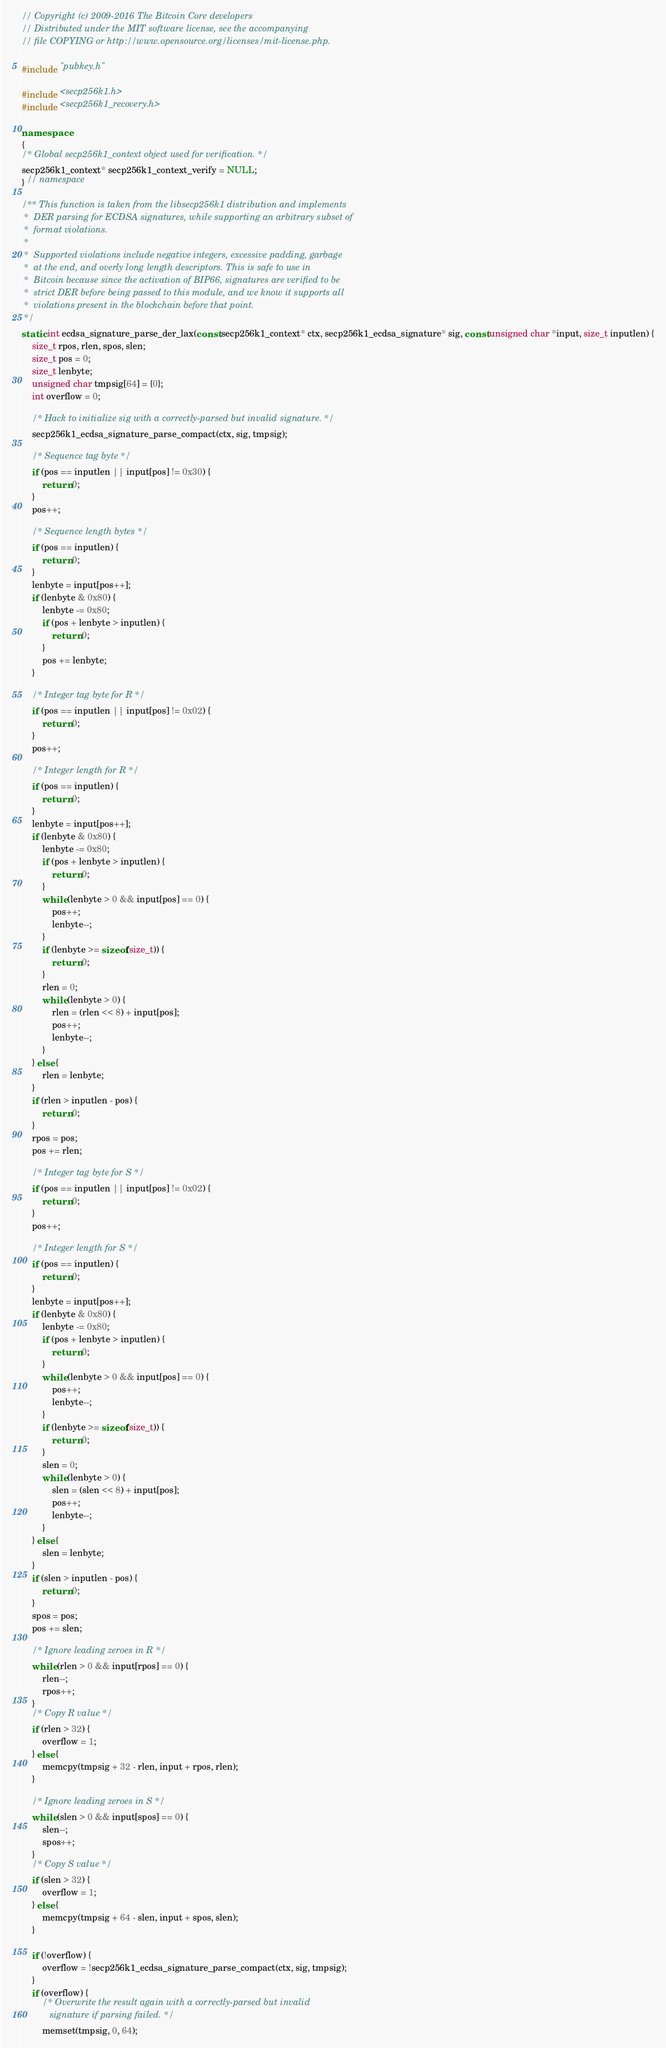Convert code to text. <code><loc_0><loc_0><loc_500><loc_500><_C++_>// Copyright (c) 2009-2016 The Bitcoin Core developers
// Distributed under the MIT software license, see the accompanying
// file COPYING or http://www.opensource.org/licenses/mit-license.php.

#include "pubkey.h"

#include <secp256k1.h>
#include <secp256k1_recovery.h>

namespace
{
/* Global secp256k1_context object used for verification. */
secp256k1_context* secp256k1_context_verify = NULL;
} // namespace

/** This function is taken from the libsecp256k1 distribution and implements
 *  DER parsing for ECDSA signatures, while supporting an arbitrary subset of
 *  format violations.
 *
 *  Supported violations include negative integers, excessive padding, garbage
 *  at the end, and overly long length descriptors. This is safe to use in
 *  Bitcoin because since the activation of BIP66, signatures are verified to be
 *  strict DER before being passed to this module, and we know it supports all
 *  violations present in the blockchain before that point.
 */
static int ecdsa_signature_parse_der_lax(const secp256k1_context* ctx, secp256k1_ecdsa_signature* sig, const unsigned char *input, size_t inputlen) {
    size_t rpos, rlen, spos, slen;
    size_t pos = 0;
    size_t lenbyte;
    unsigned char tmpsig[64] = {0};
    int overflow = 0;

    /* Hack to initialize sig with a correctly-parsed but invalid signature. */
    secp256k1_ecdsa_signature_parse_compact(ctx, sig, tmpsig);

    /* Sequence tag byte */
    if (pos == inputlen || input[pos] != 0x30) {
        return 0;
    }
    pos++;

    /* Sequence length bytes */
    if (pos == inputlen) {
        return 0;
    }
    lenbyte = input[pos++];
    if (lenbyte & 0x80) {
        lenbyte -= 0x80;
        if (pos + lenbyte > inputlen) {
            return 0;
        }
        pos += lenbyte;
    }

    /* Integer tag byte for R */
    if (pos == inputlen || input[pos] != 0x02) {
        return 0;
    }
    pos++;

    /* Integer length for R */
    if (pos == inputlen) {
        return 0;
    }
    lenbyte = input[pos++];
    if (lenbyte & 0x80) {
        lenbyte -= 0x80;
        if (pos + lenbyte > inputlen) {
            return 0;
        }
        while (lenbyte > 0 && input[pos] == 0) {
            pos++;
            lenbyte--;
        }
        if (lenbyte >= sizeof(size_t)) {
            return 0;
        }
        rlen = 0;
        while (lenbyte > 0) {
            rlen = (rlen << 8) + input[pos];
            pos++;
            lenbyte--;
        }
    } else {
        rlen = lenbyte;
    }
    if (rlen > inputlen - pos) {
        return 0;
    }
    rpos = pos;
    pos += rlen;

    /* Integer tag byte for S */
    if (pos == inputlen || input[pos] != 0x02) {
        return 0;
    }
    pos++;

    /* Integer length for S */
    if (pos == inputlen) {
        return 0;
    }
    lenbyte = input[pos++];
    if (lenbyte & 0x80) {
        lenbyte -= 0x80;
        if (pos + lenbyte > inputlen) {
            return 0;
        }
        while (lenbyte > 0 && input[pos] == 0) {
            pos++;
            lenbyte--;
        }
        if (lenbyte >= sizeof(size_t)) {
            return 0;
        }
        slen = 0;
        while (lenbyte > 0) {
            slen = (slen << 8) + input[pos];
            pos++;
            lenbyte--;
        }
    } else {
        slen = lenbyte;
    }
    if (slen > inputlen - pos) {
        return 0;
    }
    spos = pos;
    pos += slen;

    /* Ignore leading zeroes in R */
    while (rlen > 0 && input[rpos] == 0) {
        rlen--;
        rpos++;
    }
    /* Copy R value */
    if (rlen > 32) {
        overflow = 1;
    } else {
        memcpy(tmpsig + 32 - rlen, input + rpos, rlen);
    }

    /* Ignore leading zeroes in S */
    while (slen > 0 && input[spos] == 0) {
        slen--;
        spos++;
    }
    /* Copy S value */
    if (slen > 32) {
        overflow = 1;
    } else {
        memcpy(tmpsig + 64 - slen, input + spos, slen);
    }

    if (!overflow) {
        overflow = !secp256k1_ecdsa_signature_parse_compact(ctx, sig, tmpsig);
    }
    if (overflow) {
        /* Overwrite the result again with a correctly-parsed but invalid
           signature if parsing failed. */
        memset(tmpsig, 0, 64);</code> 